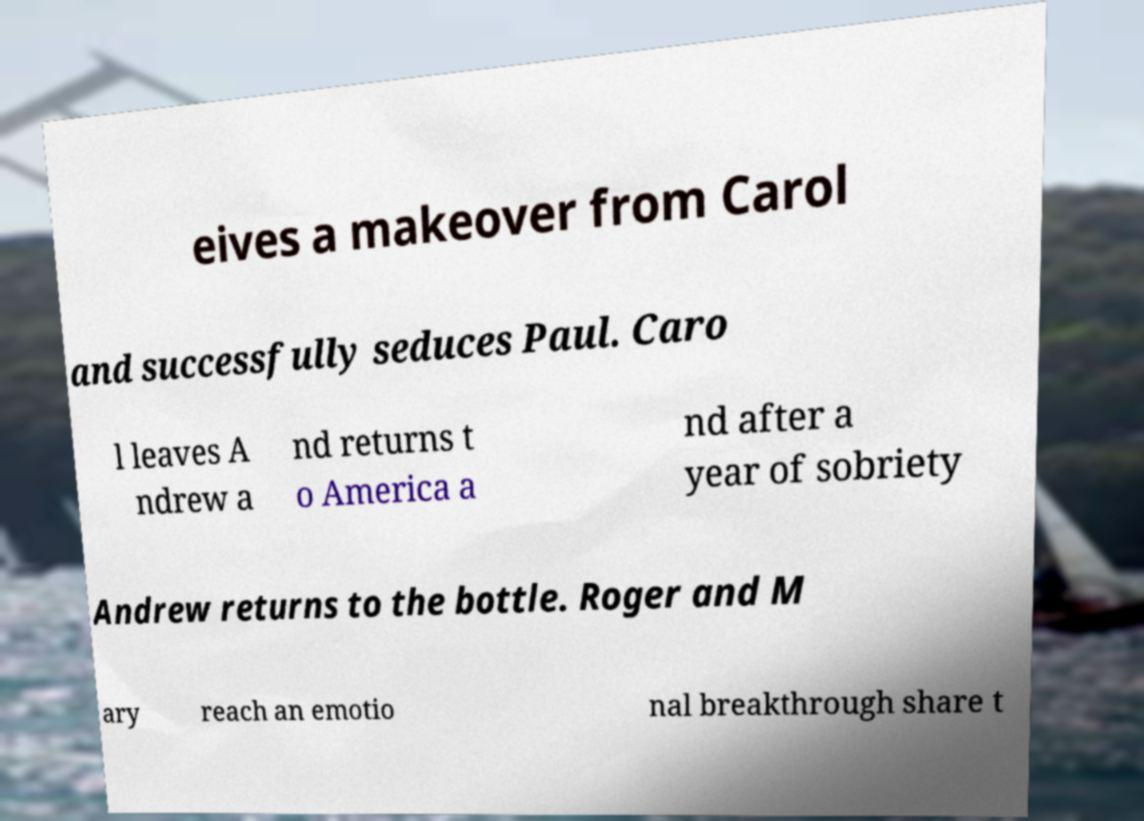What messages or text are displayed in this image? I need them in a readable, typed format. eives a makeover from Carol and successfully seduces Paul. Caro l leaves A ndrew a nd returns t o America a nd after a year of sobriety Andrew returns to the bottle. Roger and M ary reach an emotio nal breakthrough share t 